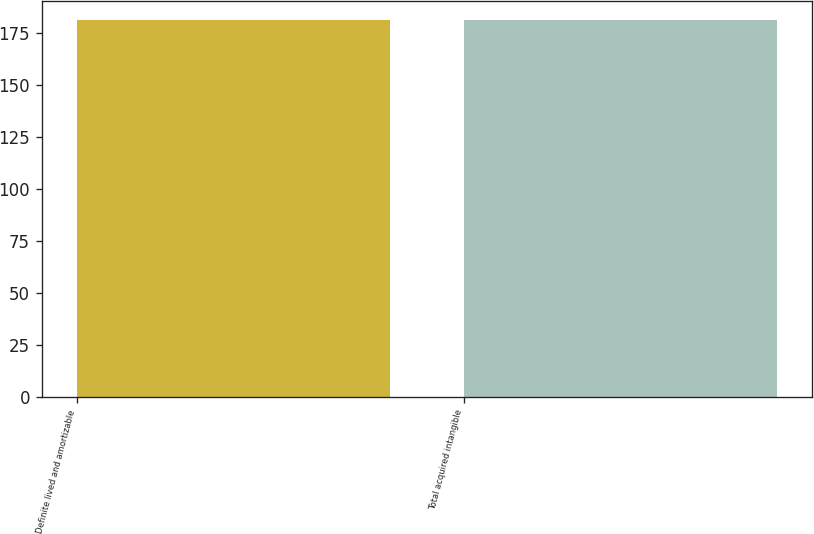<chart> <loc_0><loc_0><loc_500><loc_500><bar_chart><fcel>Definite lived and amortizable<fcel>Total acquired intangible<nl><fcel>181<fcel>181.1<nl></chart> 